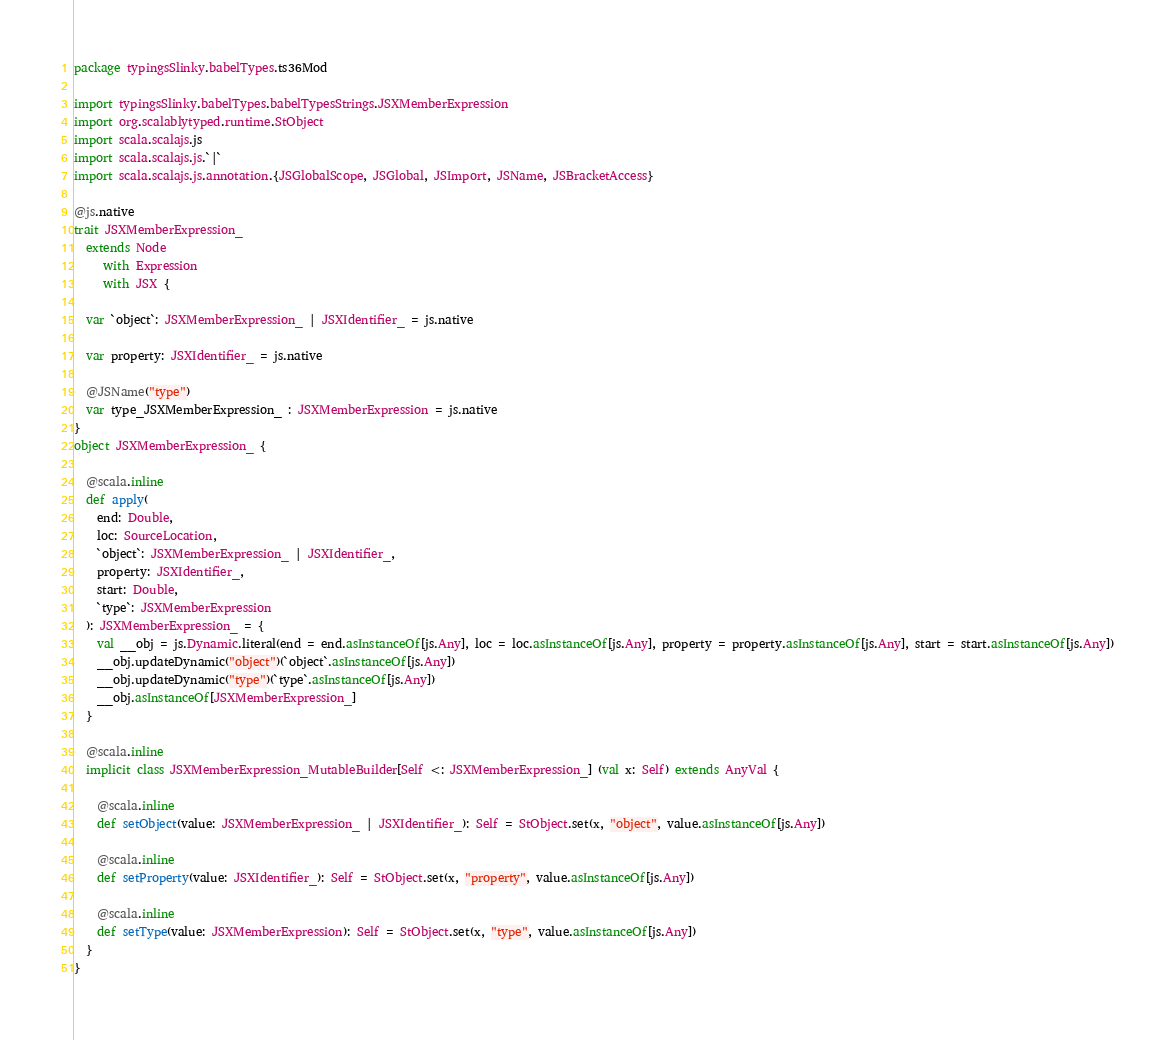<code> <loc_0><loc_0><loc_500><loc_500><_Scala_>package typingsSlinky.babelTypes.ts36Mod

import typingsSlinky.babelTypes.babelTypesStrings.JSXMemberExpression
import org.scalablytyped.runtime.StObject
import scala.scalajs.js
import scala.scalajs.js.`|`
import scala.scalajs.js.annotation.{JSGlobalScope, JSGlobal, JSImport, JSName, JSBracketAccess}

@js.native
trait JSXMemberExpression_
  extends Node
     with Expression
     with JSX {
  
  var `object`: JSXMemberExpression_ | JSXIdentifier_ = js.native
  
  var property: JSXIdentifier_ = js.native
  
  @JSName("type")
  var type_JSXMemberExpression_ : JSXMemberExpression = js.native
}
object JSXMemberExpression_ {
  
  @scala.inline
  def apply(
    end: Double,
    loc: SourceLocation,
    `object`: JSXMemberExpression_ | JSXIdentifier_,
    property: JSXIdentifier_,
    start: Double,
    `type`: JSXMemberExpression
  ): JSXMemberExpression_ = {
    val __obj = js.Dynamic.literal(end = end.asInstanceOf[js.Any], loc = loc.asInstanceOf[js.Any], property = property.asInstanceOf[js.Any], start = start.asInstanceOf[js.Any])
    __obj.updateDynamic("object")(`object`.asInstanceOf[js.Any])
    __obj.updateDynamic("type")(`type`.asInstanceOf[js.Any])
    __obj.asInstanceOf[JSXMemberExpression_]
  }
  
  @scala.inline
  implicit class JSXMemberExpression_MutableBuilder[Self <: JSXMemberExpression_] (val x: Self) extends AnyVal {
    
    @scala.inline
    def setObject(value: JSXMemberExpression_ | JSXIdentifier_): Self = StObject.set(x, "object", value.asInstanceOf[js.Any])
    
    @scala.inline
    def setProperty(value: JSXIdentifier_): Self = StObject.set(x, "property", value.asInstanceOf[js.Any])
    
    @scala.inline
    def setType(value: JSXMemberExpression): Self = StObject.set(x, "type", value.asInstanceOf[js.Any])
  }
}
</code> 